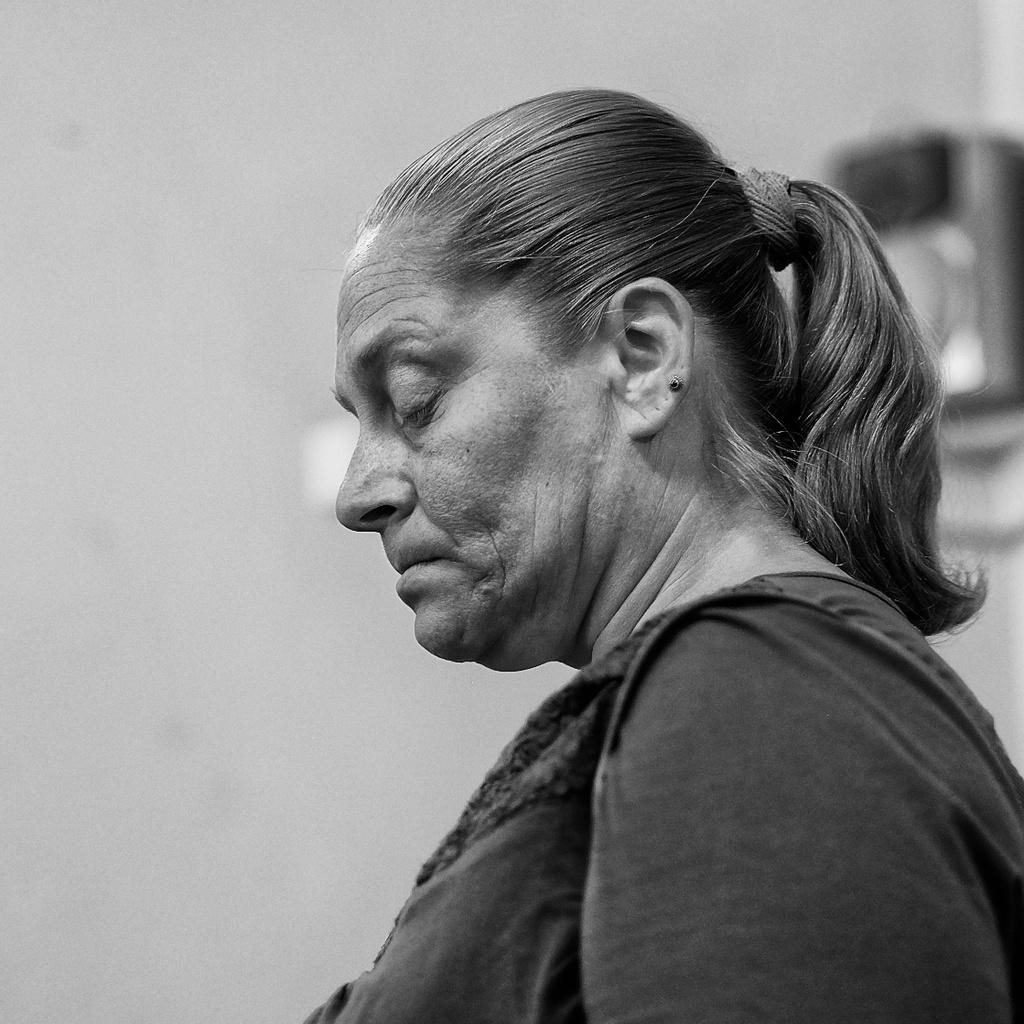Who is the main subject in the foreground of the image? There is a woman in the foreground of the image. What can be seen in the background of the image? There is a wall and objects in the background of the image. What type of rod is being used by the woman in the image? There is no rod visible in the image; the woman is not holding or using any such object. 